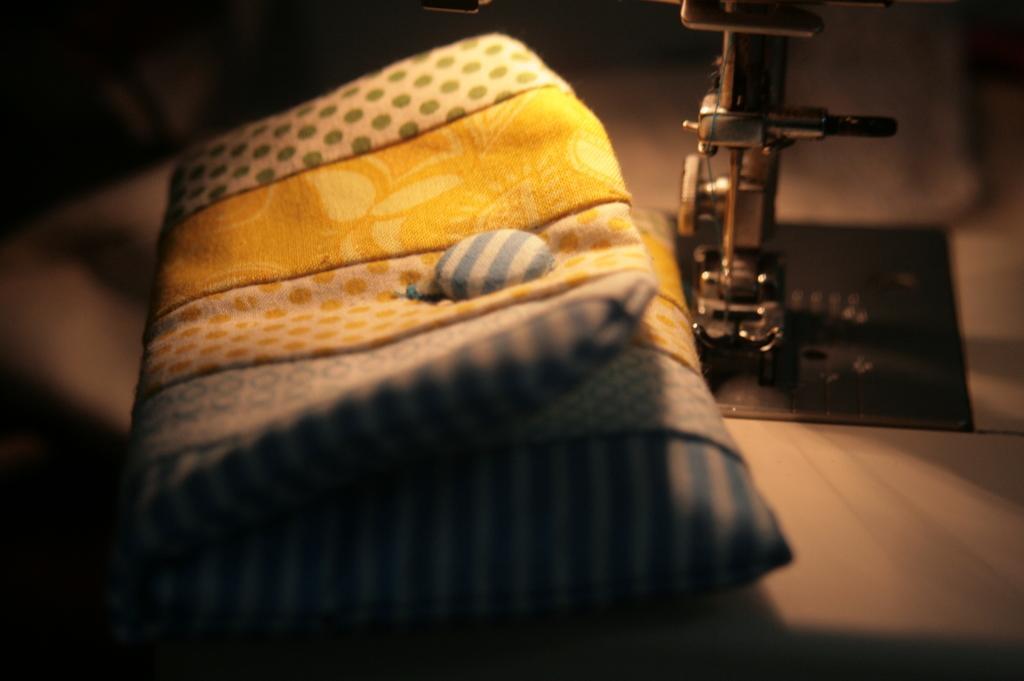How would you summarize this image in a sentence or two? In this image in front there is a pillow and there is an object, which is on the black colour mat. 